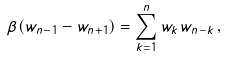Convert formula to latex. <formula><loc_0><loc_0><loc_500><loc_500>\beta ( w _ { n - 1 } - w _ { n + 1 } ) = \sum _ { k = 1 } ^ { n } w _ { k } w _ { n - k } \, ,</formula> 